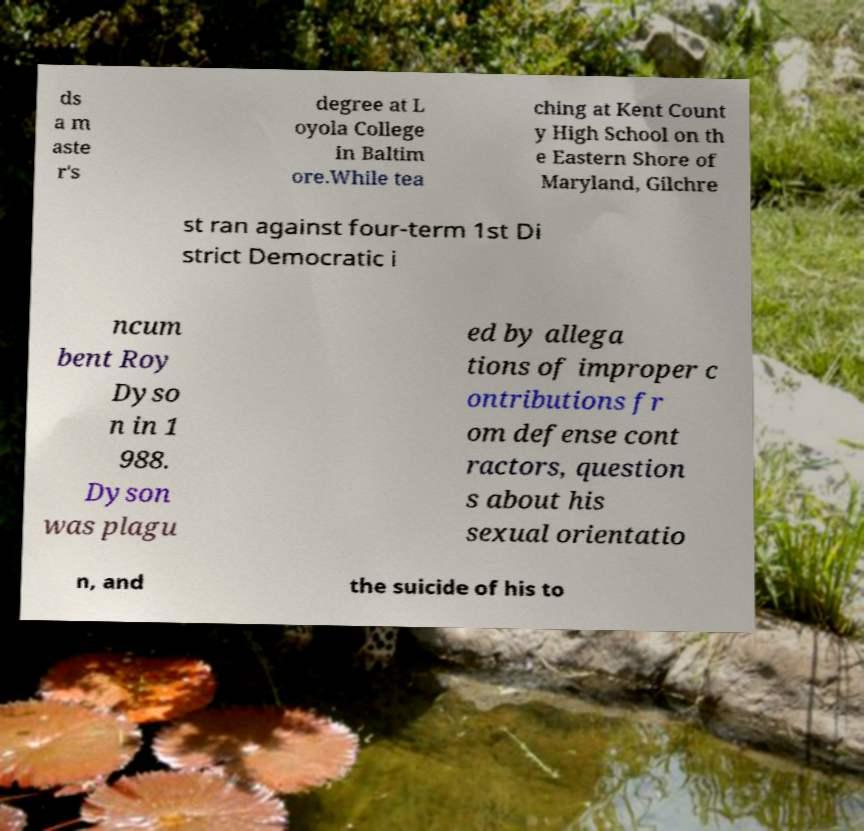Please identify and transcribe the text found in this image. ds a m aste r's degree at L oyola College in Baltim ore.While tea ching at Kent Count y High School on th e Eastern Shore of Maryland, Gilchre st ran against four-term 1st Di strict Democratic i ncum bent Roy Dyso n in 1 988. Dyson was plagu ed by allega tions of improper c ontributions fr om defense cont ractors, question s about his sexual orientatio n, and the suicide of his to 